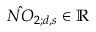<formula> <loc_0><loc_0><loc_500><loc_500>\hat { N O } _ { 2 ; d , s } \in \mathbb { R }</formula> 